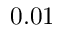Convert formula to latex. <formula><loc_0><loc_0><loc_500><loc_500>0 . 0 1</formula> 